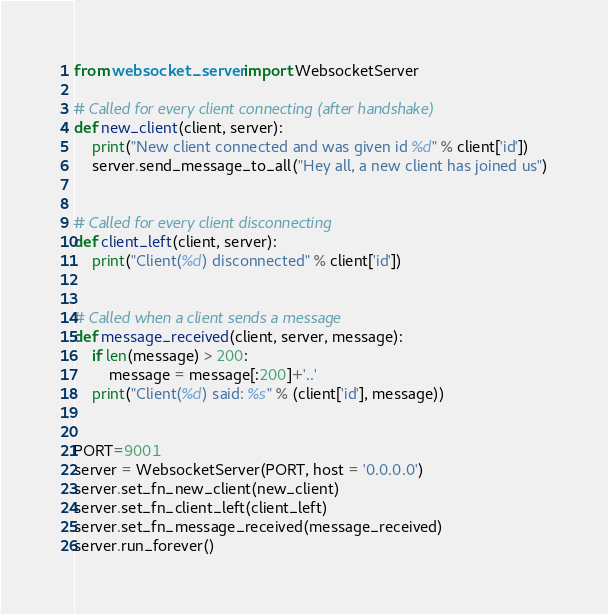Convert code to text. <code><loc_0><loc_0><loc_500><loc_500><_Python_>from websocket_server import WebsocketServer

# Called for every client connecting (after handshake)
def new_client(client, server):
	print("New client connected and was given id %d" % client['id'])
	server.send_message_to_all("Hey all, a new client has joined us")


# Called for every client disconnecting
def client_left(client, server):
	print("Client(%d) disconnected" % client['id'])


# Called when a client sends a message
def message_received(client, server, message):
	if len(message) > 200:
		message = message[:200]+'..'
	print("Client(%d) said: %s" % (client['id'], message))


PORT=9001
server = WebsocketServer(PORT, host = '0.0.0.0')
server.set_fn_new_client(new_client)
server.set_fn_client_left(client_left)
server.set_fn_message_received(message_received)
server.run_forever()
</code> 